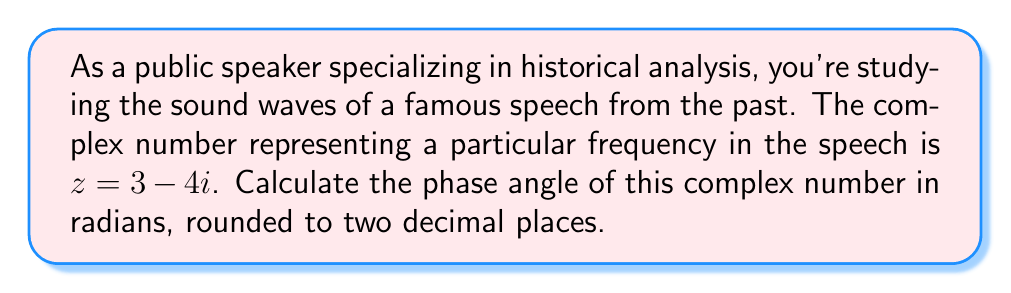Can you solve this math problem? To calculate the phase angle of a complex number $z = a + bi$, we use the arctangent function:

$$ \theta = \arctan\left(\frac{b}{a}\right) $$

However, we need to be careful about which quadrant the complex number is in. For $z = 3 - 4i$:

1. Real part $a = 3$ (positive)
2. Imaginary part $b = -4$ (negative)

This places our complex number in the fourth quadrant.

For the fourth quadrant, we need to add $2\pi$ to the result of $\arctan\left(\frac{b}{a}\right)$:

$$ \theta = \arctan\left(\frac{b}{a}\right) + 2\pi $$

Substituting our values:

$$ \theta = \arctan\left(\frac{-4}{3}\right) + 2\pi $$

$$ \theta = -0.9272952180 + 6.2831853072 $$

$$ \theta = 5.3558900892 $$

Rounding to two decimal places:

$$ \theta \approx 5.36 \text{ radians} $$

This phase angle represents the initial angle of the sound wave in the complex plane, which could be related to the timing or emphasis in the historical speech.
Answer: $5.36$ radians 